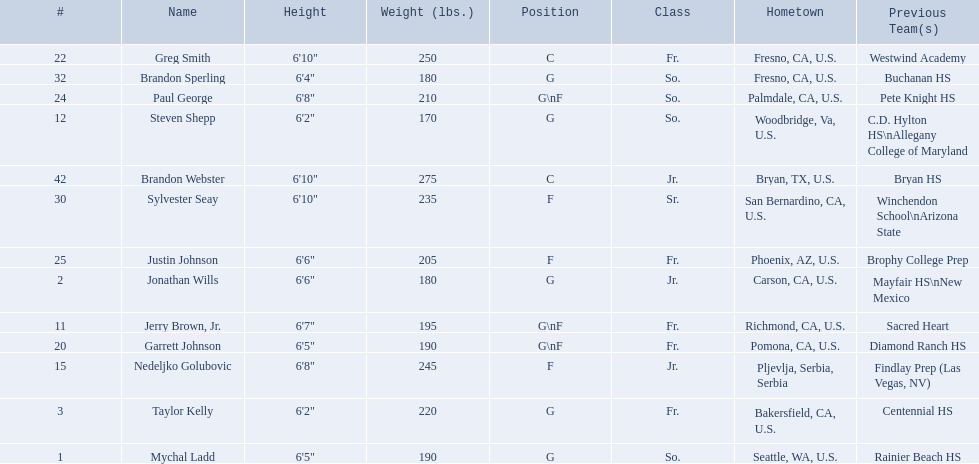Who are the players for the 2009-10 fresno state bulldogs men's basketball team? Mychal Ladd, Jonathan Wills, Taylor Kelly, Jerry Brown, Jr., Steven Shepp, Nedeljko Golubovic, Garrett Johnson, Greg Smith, Paul George, Justin Johnson, Sylvester Seay, Brandon Sperling, Brandon Webster. What are their heights? 6'5", 6'6", 6'2", 6'7", 6'2", 6'8", 6'5", 6'10", 6'8", 6'6", 6'10", 6'4", 6'10". What is the shortest height? 6'2", 6'2". What is the lowest weight? 6'2". Which player is it? Steven Shepp. 